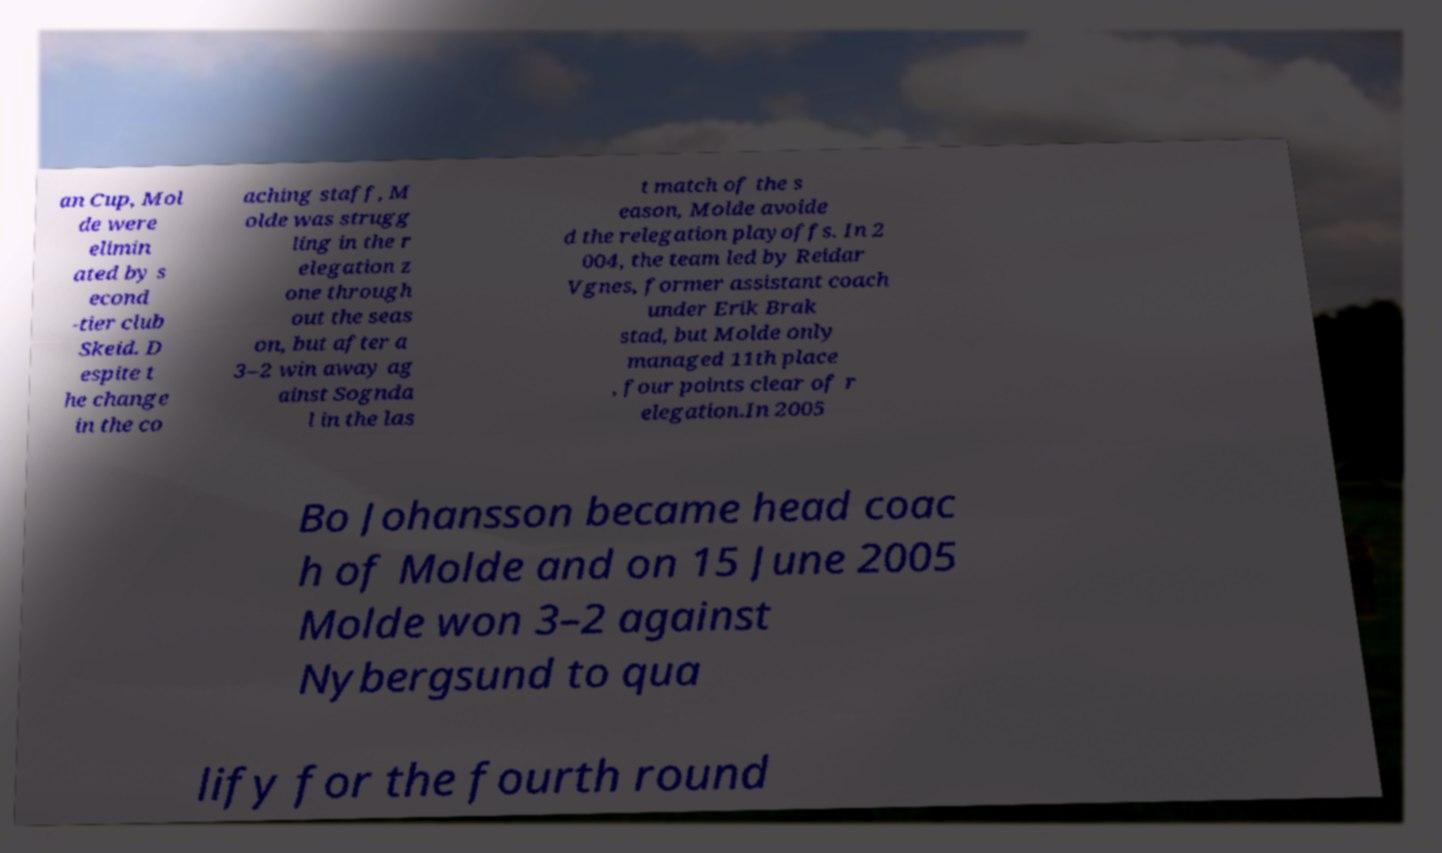I need the written content from this picture converted into text. Can you do that? an Cup, Mol de were elimin ated by s econd -tier club Skeid. D espite t he change in the co aching staff, M olde was strugg ling in the r elegation z one through out the seas on, but after a 3–2 win away ag ainst Sognda l in the las t match of the s eason, Molde avoide d the relegation playoffs. In 2 004, the team led by Reidar Vgnes, former assistant coach under Erik Brak stad, but Molde only managed 11th place , four points clear of r elegation.In 2005 Bo Johansson became head coac h of Molde and on 15 June 2005 Molde won 3–2 against Nybergsund to qua lify for the fourth round 